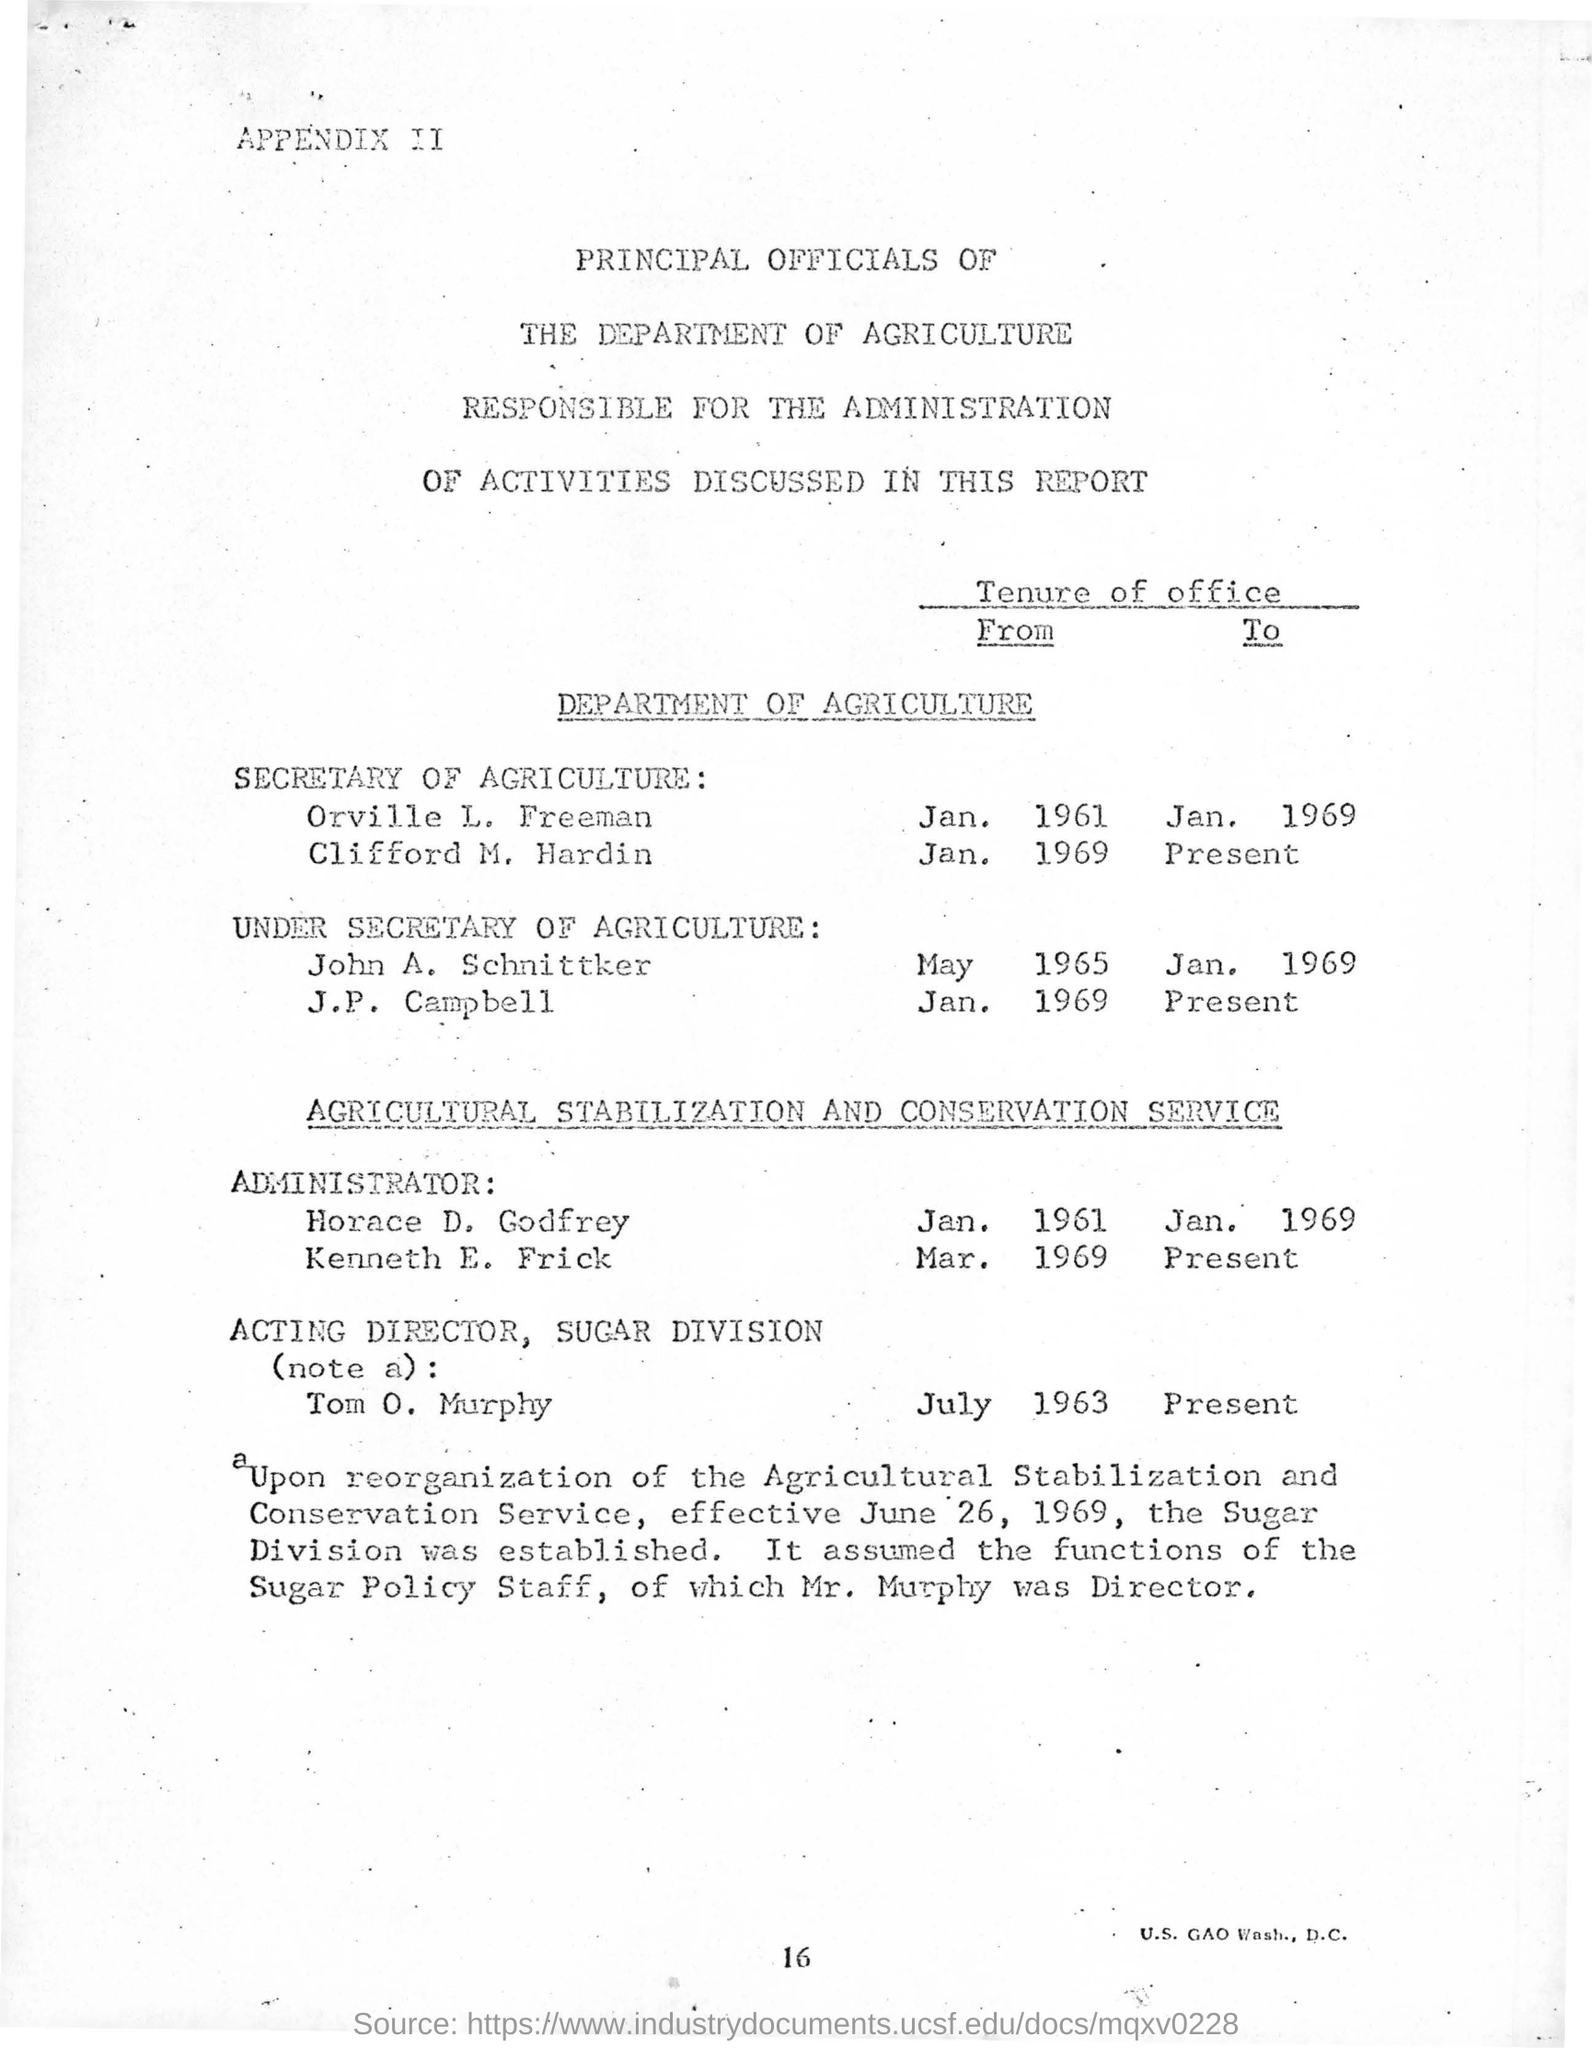Identify some key points in this picture. Orville L. Freeman served as the Secretary of Agriculture from January 1961 to January 1969. John A. Schnittker was the Under Secretary of Agriculture from May 1965 to January 1969. 